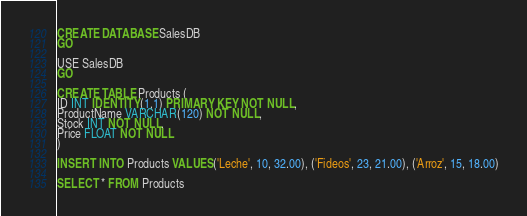Convert code to text. <code><loc_0><loc_0><loc_500><loc_500><_SQL_>CREATE DATABASE SalesDB
GO

USE SalesDB
GO

CREATE TABLE Products (
ID INT IDENTITY(1,1) PRIMARY KEY NOT NULL,
ProductName VARCHAR(120) NOT NULL,
Stock INT NOT NULL,
Price FLOAT NOT NULL 
)

INSERT INTO Products VALUES('Leche', 10, 32.00), ('Fideos', 23, 21.00), ('Arroz', 15, 18.00)

SELECT * FROM Products</code> 